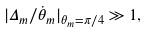<formula> <loc_0><loc_0><loc_500><loc_500>| \Delta _ { m } / \dot { \theta } _ { m } | _ { \theta _ { m } = \pi / 4 } \gg 1 ,</formula> 